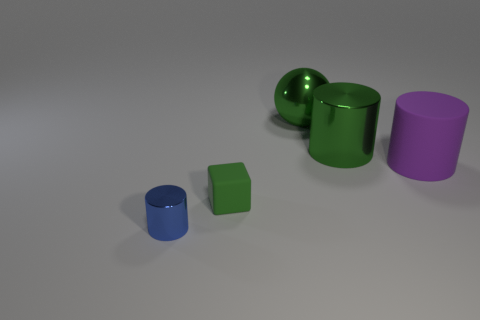Add 2 blue cylinders. How many objects exist? 7 Subtract all cylinders. How many objects are left? 2 Subtract 1 green spheres. How many objects are left? 4 Subtract all tiny metal cylinders. Subtract all large purple shiny cylinders. How many objects are left? 4 Add 5 blocks. How many blocks are left? 6 Add 4 tiny red spheres. How many tiny red spheres exist? 4 